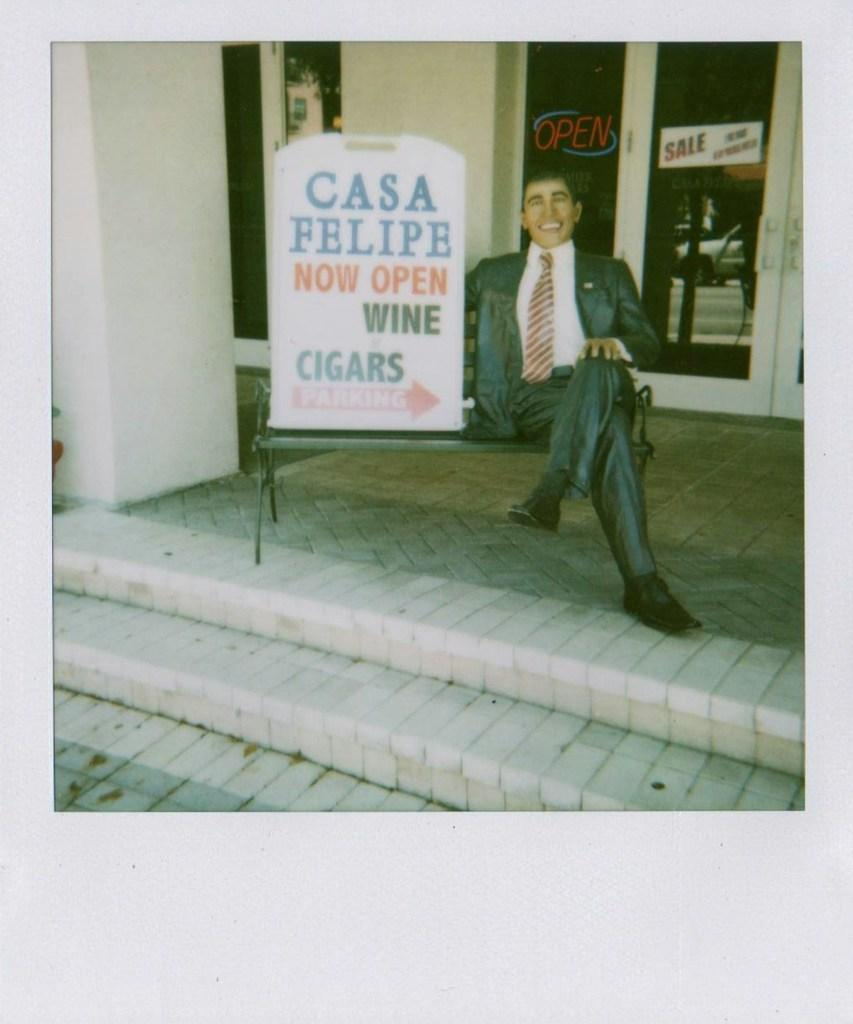What is the person in the image doing? There is a person sitting in the image. What is behind the person? There is a board behind the person. What is the person sitting on? There is a chair in the image. What architectural feature can be seen in the foreground of the image? There are steps in the foreground of the image. What is the main structure in the image? There is a wall in the image. What type of door is visible in the background of the image? There is a glass door in the background of the image. What type of rhythm can be heard coming from the dust in the image? There is no dust present in the image, and therefore no rhythm can be heard. 